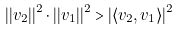Convert formula to latex. <formula><loc_0><loc_0><loc_500><loc_500>| | { v } _ { 2 } | | ^ { 2 } \cdot | | { v } _ { 1 } | | ^ { 2 } > | \langle { v } _ { 2 } , { v } _ { 1 } \rangle | ^ { 2 }</formula> 